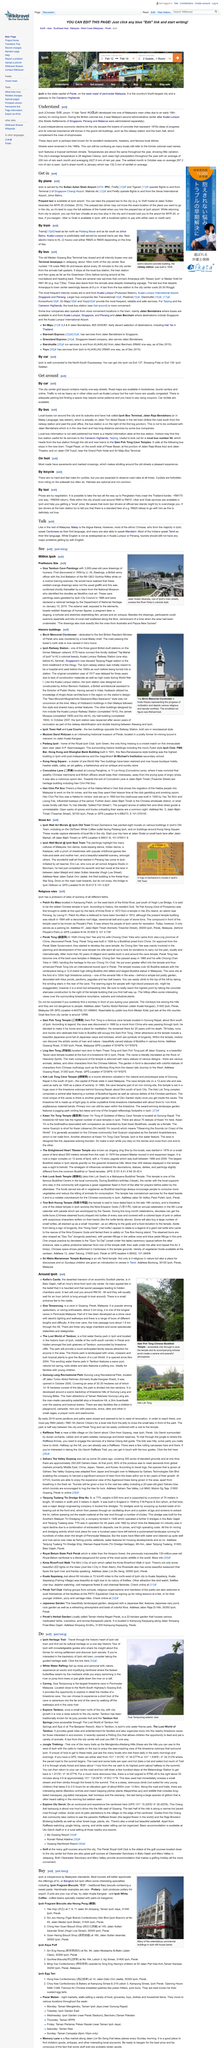Mention a couple of crucial points in this snapshot. Taxi fares are not set in stone and are subject to negotiation. This image depicts the Birch Memorial Clocktower, which is a structure known for its architectural significance and historical value. It is not permissible for cyclists to ride on the pavement. Ernest Zacharevic has painted eight murals in Ipoh's Old Town. It is a fact that a significant number of cyclists do not use helmets. 